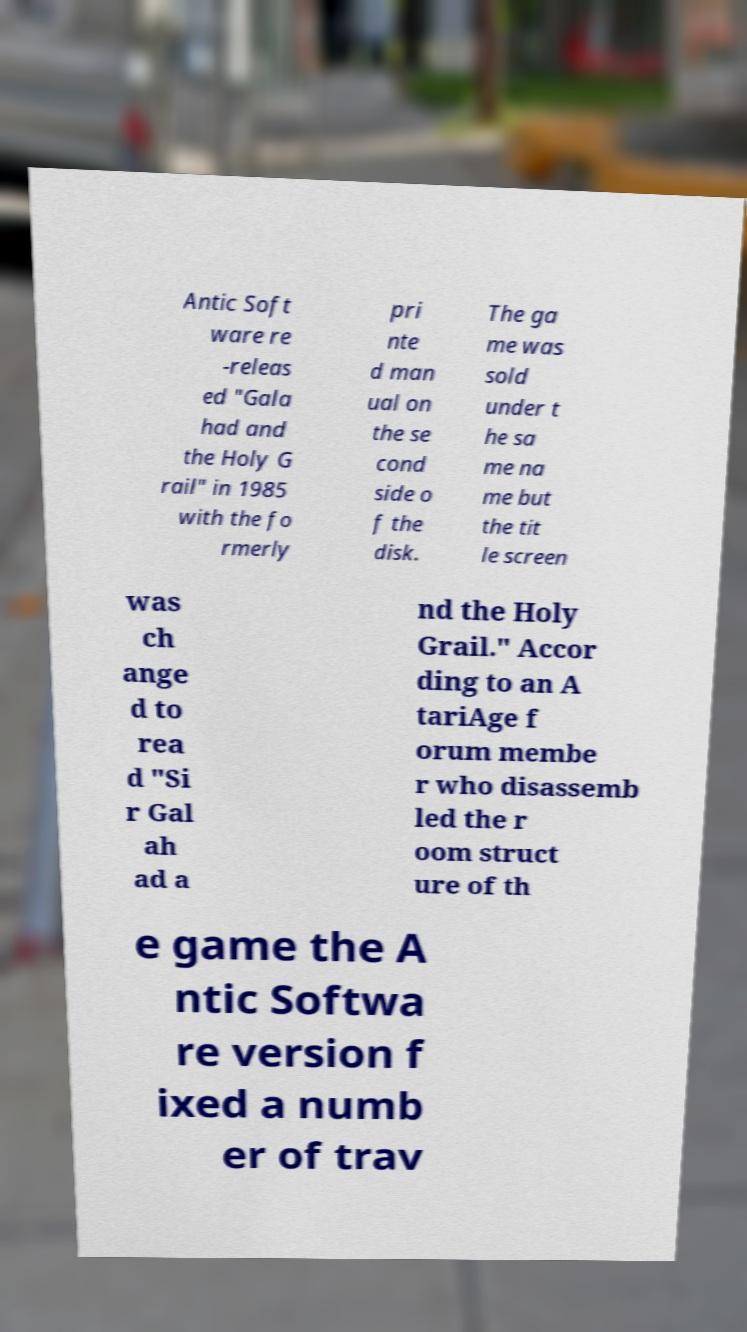What messages or text are displayed in this image? I need them in a readable, typed format. Antic Soft ware re -releas ed "Gala had and the Holy G rail" in 1985 with the fo rmerly pri nte d man ual on the se cond side o f the disk. The ga me was sold under t he sa me na me but the tit le screen was ch ange d to rea d "Si r Gal ah ad a nd the Holy Grail." Accor ding to an A tariAge f orum membe r who disassemb led the r oom struct ure of th e game the A ntic Softwa re version f ixed a numb er of trav 